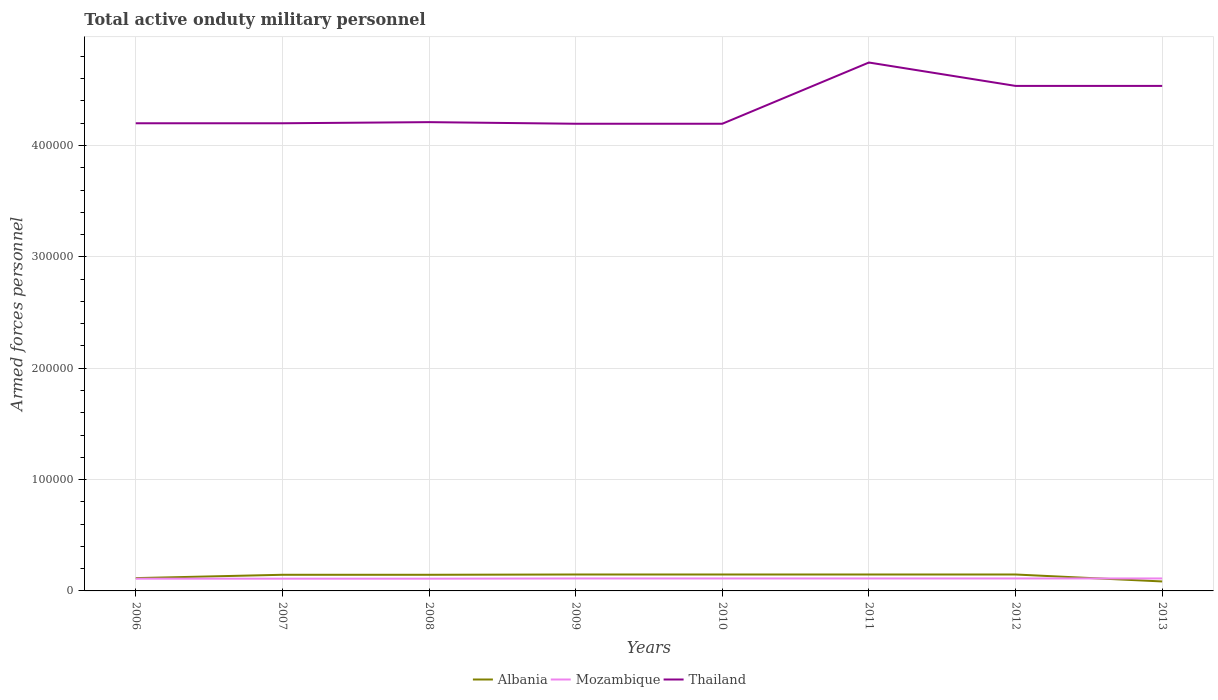How many different coloured lines are there?
Offer a very short reply. 3. Does the line corresponding to Mozambique intersect with the line corresponding to Albania?
Keep it short and to the point. Yes. Is the number of lines equal to the number of legend labels?
Your answer should be compact. Yes. Across all years, what is the maximum number of armed forces personnel in Albania?
Provide a short and direct response. 8500. What is the total number of armed forces personnel in Albania in the graph?
Provide a succinct answer. -3000. What is the difference between the highest and the second highest number of armed forces personnel in Albania?
Keep it short and to the point. 6250. How many lines are there?
Your answer should be very brief. 3. Are the values on the major ticks of Y-axis written in scientific E-notation?
Make the answer very short. No. What is the title of the graph?
Give a very brief answer. Total active onduty military personnel. Does "Bangladesh" appear as one of the legend labels in the graph?
Make the answer very short. No. What is the label or title of the X-axis?
Your answer should be very brief. Years. What is the label or title of the Y-axis?
Give a very brief answer. Armed forces personnel. What is the Armed forces personnel in Albania in 2006?
Offer a terse response. 1.15e+04. What is the Armed forces personnel in Mozambique in 2006?
Your answer should be compact. 1.10e+04. What is the Armed forces personnel of Albania in 2007?
Provide a short and direct response. 1.45e+04. What is the Armed forces personnel of Mozambique in 2007?
Offer a terse response. 1.10e+04. What is the Armed forces personnel in Thailand in 2007?
Keep it short and to the point. 4.20e+05. What is the Armed forces personnel of Albania in 2008?
Your response must be concise. 1.45e+04. What is the Armed forces personnel of Mozambique in 2008?
Ensure brevity in your answer.  1.10e+04. What is the Armed forces personnel of Thailand in 2008?
Provide a succinct answer. 4.21e+05. What is the Armed forces personnel in Albania in 2009?
Provide a succinct answer. 1.47e+04. What is the Armed forces personnel in Mozambique in 2009?
Your response must be concise. 1.12e+04. What is the Armed forces personnel in Thailand in 2009?
Ensure brevity in your answer.  4.20e+05. What is the Armed forces personnel in Albania in 2010?
Ensure brevity in your answer.  1.47e+04. What is the Armed forces personnel in Mozambique in 2010?
Provide a short and direct response. 1.12e+04. What is the Armed forces personnel in Thailand in 2010?
Offer a terse response. 4.20e+05. What is the Armed forces personnel in Albania in 2011?
Provide a short and direct response. 1.48e+04. What is the Armed forces personnel in Mozambique in 2011?
Your response must be concise. 1.12e+04. What is the Armed forces personnel of Thailand in 2011?
Ensure brevity in your answer.  4.75e+05. What is the Armed forces personnel in Albania in 2012?
Ensure brevity in your answer.  1.48e+04. What is the Armed forces personnel of Mozambique in 2012?
Offer a very short reply. 1.12e+04. What is the Armed forces personnel in Thailand in 2012?
Keep it short and to the point. 4.54e+05. What is the Armed forces personnel of Albania in 2013?
Provide a succinct answer. 8500. What is the Armed forces personnel of Mozambique in 2013?
Ensure brevity in your answer.  1.12e+04. What is the Armed forces personnel of Thailand in 2013?
Your response must be concise. 4.54e+05. Across all years, what is the maximum Armed forces personnel in Albania?
Ensure brevity in your answer.  1.48e+04. Across all years, what is the maximum Armed forces personnel of Mozambique?
Provide a succinct answer. 1.12e+04. Across all years, what is the maximum Armed forces personnel of Thailand?
Your answer should be compact. 4.75e+05. Across all years, what is the minimum Armed forces personnel in Albania?
Provide a succinct answer. 8500. Across all years, what is the minimum Armed forces personnel in Mozambique?
Your answer should be very brief. 1.10e+04. Across all years, what is the minimum Armed forces personnel of Thailand?
Offer a terse response. 4.20e+05. What is the total Armed forces personnel of Albania in the graph?
Make the answer very short. 1.08e+05. What is the total Armed forces personnel of Mozambique in the graph?
Offer a terse response. 8.90e+04. What is the total Armed forces personnel in Thailand in the graph?
Offer a very short reply. 3.48e+06. What is the difference between the Armed forces personnel of Albania in 2006 and that in 2007?
Give a very brief answer. -3000. What is the difference between the Armed forces personnel of Mozambique in 2006 and that in 2007?
Your answer should be compact. 0. What is the difference between the Armed forces personnel in Thailand in 2006 and that in 2007?
Your response must be concise. 0. What is the difference between the Armed forces personnel in Albania in 2006 and that in 2008?
Your answer should be very brief. -3000. What is the difference between the Armed forces personnel in Mozambique in 2006 and that in 2008?
Your answer should be very brief. 0. What is the difference between the Armed forces personnel of Thailand in 2006 and that in 2008?
Provide a succinct answer. -1000. What is the difference between the Armed forces personnel in Albania in 2006 and that in 2009?
Provide a succinct answer. -3245. What is the difference between the Armed forces personnel in Mozambique in 2006 and that in 2009?
Provide a succinct answer. -200. What is the difference between the Armed forces personnel of Thailand in 2006 and that in 2009?
Give a very brief answer. 440. What is the difference between the Armed forces personnel of Albania in 2006 and that in 2010?
Keep it short and to the point. -3245. What is the difference between the Armed forces personnel of Mozambique in 2006 and that in 2010?
Ensure brevity in your answer.  -200. What is the difference between the Armed forces personnel in Thailand in 2006 and that in 2010?
Offer a very short reply. 440. What is the difference between the Armed forces personnel of Albania in 2006 and that in 2011?
Your answer should be compact. -3250. What is the difference between the Armed forces personnel of Mozambique in 2006 and that in 2011?
Provide a succinct answer. -200. What is the difference between the Armed forces personnel of Thailand in 2006 and that in 2011?
Offer a terse response. -5.46e+04. What is the difference between the Armed forces personnel in Albania in 2006 and that in 2012?
Offer a very short reply. -3250. What is the difference between the Armed forces personnel of Mozambique in 2006 and that in 2012?
Keep it short and to the point. -200. What is the difference between the Armed forces personnel in Thailand in 2006 and that in 2012?
Your answer should be very brief. -3.36e+04. What is the difference between the Armed forces personnel of Albania in 2006 and that in 2013?
Ensure brevity in your answer.  3000. What is the difference between the Armed forces personnel in Mozambique in 2006 and that in 2013?
Give a very brief answer. -200. What is the difference between the Armed forces personnel of Thailand in 2006 and that in 2013?
Give a very brief answer. -3.36e+04. What is the difference between the Armed forces personnel of Albania in 2007 and that in 2008?
Your answer should be very brief. 0. What is the difference between the Armed forces personnel in Mozambique in 2007 and that in 2008?
Ensure brevity in your answer.  0. What is the difference between the Armed forces personnel of Thailand in 2007 and that in 2008?
Your answer should be very brief. -1000. What is the difference between the Armed forces personnel in Albania in 2007 and that in 2009?
Ensure brevity in your answer.  -245. What is the difference between the Armed forces personnel of Mozambique in 2007 and that in 2009?
Your answer should be compact. -200. What is the difference between the Armed forces personnel in Thailand in 2007 and that in 2009?
Offer a terse response. 440. What is the difference between the Armed forces personnel of Albania in 2007 and that in 2010?
Make the answer very short. -245. What is the difference between the Armed forces personnel in Mozambique in 2007 and that in 2010?
Provide a short and direct response. -200. What is the difference between the Armed forces personnel of Thailand in 2007 and that in 2010?
Keep it short and to the point. 440. What is the difference between the Armed forces personnel in Albania in 2007 and that in 2011?
Your answer should be very brief. -250. What is the difference between the Armed forces personnel of Mozambique in 2007 and that in 2011?
Ensure brevity in your answer.  -200. What is the difference between the Armed forces personnel of Thailand in 2007 and that in 2011?
Keep it short and to the point. -5.46e+04. What is the difference between the Armed forces personnel of Albania in 2007 and that in 2012?
Keep it short and to the point. -250. What is the difference between the Armed forces personnel in Mozambique in 2007 and that in 2012?
Offer a terse response. -200. What is the difference between the Armed forces personnel of Thailand in 2007 and that in 2012?
Provide a succinct answer. -3.36e+04. What is the difference between the Armed forces personnel in Albania in 2007 and that in 2013?
Provide a succinct answer. 6000. What is the difference between the Armed forces personnel of Mozambique in 2007 and that in 2013?
Ensure brevity in your answer.  -200. What is the difference between the Armed forces personnel in Thailand in 2007 and that in 2013?
Give a very brief answer. -3.36e+04. What is the difference between the Armed forces personnel of Albania in 2008 and that in 2009?
Your answer should be compact. -245. What is the difference between the Armed forces personnel of Mozambique in 2008 and that in 2009?
Provide a succinct answer. -200. What is the difference between the Armed forces personnel of Thailand in 2008 and that in 2009?
Your answer should be very brief. 1440. What is the difference between the Armed forces personnel of Albania in 2008 and that in 2010?
Your response must be concise. -245. What is the difference between the Armed forces personnel of Mozambique in 2008 and that in 2010?
Provide a succinct answer. -200. What is the difference between the Armed forces personnel in Thailand in 2008 and that in 2010?
Give a very brief answer. 1440. What is the difference between the Armed forces personnel in Albania in 2008 and that in 2011?
Your answer should be compact. -250. What is the difference between the Armed forces personnel in Mozambique in 2008 and that in 2011?
Give a very brief answer. -200. What is the difference between the Armed forces personnel of Thailand in 2008 and that in 2011?
Make the answer very short. -5.36e+04. What is the difference between the Armed forces personnel of Albania in 2008 and that in 2012?
Offer a terse response. -250. What is the difference between the Armed forces personnel of Mozambique in 2008 and that in 2012?
Offer a very short reply. -200. What is the difference between the Armed forces personnel of Thailand in 2008 and that in 2012?
Offer a terse response. -3.26e+04. What is the difference between the Armed forces personnel in Albania in 2008 and that in 2013?
Make the answer very short. 6000. What is the difference between the Armed forces personnel in Mozambique in 2008 and that in 2013?
Your answer should be very brief. -200. What is the difference between the Armed forces personnel in Thailand in 2008 and that in 2013?
Make the answer very short. -3.26e+04. What is the difference between the Armed forces personnel of Mozambique in 2009 and that in 2010?
Make the answer very short. 0. What is the difference between the Armed forces personnel in Mozambique in 2009 and that in 2011?
Provide a short and direct response. 0. What is the difference between the Armed forces personnel of Thailand in 2009 and that in 2011?
Offer a terse response. -5.50e+04. What is the difference between the Armed forces personnel of Thailand in 2009 and that in 2012?
Keep it short and to the point. -3.40e+04. What is the difference between the Armed forces personnel of Albania in 2009 and that in 2013?
Offer a very short reply. 6245. What is the difference between the Armed forces personnel in Mozambique in 2009 and that in 2013?
Give a very brief answer. 0. What is the difference between the Armed forces personnel of Thailand in 2009 and that in 2013?
Make the answer very short. -3.40e+04. What is the difference between the Armed forces personnel of Thailand in 2010 and that in 2011?
Keep it short and to the point. -5.50e+04. What is the difference between the Armed forces personnel of Thailand in 2010 and that in 2012?
Offer a very short reply. -3.40e+04. What is the difference between the Armed forces personnel of Albania in 2010 and that in 2013?
Keep it short and to the point. 6245. What is the difference between the Armed forces personnel of Mozambique in 2010 and that in 2013?
Make the answer very short. 0. What is the difference between the Armed forces personnel in Thailand in 2010 and that in 2013?
Your answer should be very brief. -3.40e+04. What is the difference between the Armed forces personnel in Albania in 2011 and that in 2012?
Your response must be concise. 0. What is the difference between the Armed forces personnel of Mozambique in 2011 and that in 2012?
Offer a very short reply. 0. What is the difference between the Armed forces personnel of Thailand in 2011 and that in 2012?
Make the answer very short. 2.10e+04. What is the difference between the Armed forces personnel in Albania in 2011 and that in 2013?
Give a very brief answer. 6250. What is the difference between the Armed forces personnel of Thailand in 2011 and that in 2013?
Keep it short and to the point. 2.10e+04. What is the difference between the Armed forces personnel of Albania in 2012 and that in 2013?
Make the answer very short. 6250. What is the difference between the Armed forces personnel in Mozambique in 2012 and that in 2013?
Provide a succinct answer. 0. What is the difference between the Armed forces personnel of Thailand in 2012 and that in 2013?
Offer a very short reply. 0. What is the difference between the Armed forces personnel in Albania in 2006 and the Armed forces personnel in Thailand in 2007?
Your answer should be very brief. -4.08e+05. What is the difference between the Armed forces personnel in Mozambique in 2006 and the Armed forces personnel in Thailand in 2007?
Provide a succinct answer. -4.09e+05. What is the difference between the Armed forces personnel of Albania in 2006 and the Armed forces personnel of Mozambique in 2008?
Make the answer very short. 500. What is the difference between the Armed forces personnel of Albania in 2006 and the Armed forces personnel of Thailand in 2008?
Your answer should be very brief. -4.10e+05. What is the difference between the Armed forces personnel in Mozambique in 2006 and the Armed forces personnel in Thailand in 2008?
Your response must be concise. -4.10e+05. What is the difference between the Armed forces personnel of Albania in 2006 and the Armed forces personnel of Mozambique in 2009?
Your response must be concise. 300. What is the difference between the Armed forces personnel of Albania in 2006 and the Armed forces personnel of Thailand in 2009?
Your answer should be very brief. -4.08e+05. What is the difference between the Armed forces personnel in Mozambique in 2006 and the Armed forces personnel in Thailand in 2009?
Your response must be concise. -4.09e+05. What is the difference between the Armed forces personnel in Albania in 2006 and the Armed forces personnel in Mozambique in 2010?
Your answer should be very brief. 300. What is the difference between the Armed forces personnel of Albania in 2006 and the Armed forces personnel of Thailand in 2010?
Offer a very short reply. -4.08e+05. What is the difference between the Armed forces personnel in Mozambique in 2006 and the Armed forces personnel in Thailand in 2010?
Keep it short and to the point. -4.09e+05. What is the difference between the Armed forces personnel of Albania in 2006 and the Armed forces personnel of Mozambique in 2011?
Offer a terse response. 300. What is the difference between the Armed forces personnel in Albania in 2006 and the Armed forces personnel in Thailand in 2011?
Your answer should be very brief. -4.63e+05. What is the difference between the Armed forces personnel of Mozambique in 2006 and the Armed forces personnel of Thailand in 2011?
Ensure brevity in your answer.  -4.64e+05. What is the difference between the Armed forces personnel of Albania in 2006 and the Armed forces personnel of Mozambique in 2012?
Provide a short and direct response. 300. What is the difference between the Armed forces personnel of Albania in 2006 and the Armed forces personnel of Thailand in 2012?
Offer a terse response. -4.42e+05. What is the difference between the Armed forces personnel of Mozambique in 2006 and the Armed forces personnel of Thailand in 2012?
Ensure brevity in your answer.  -4.43e+05. What is the difference between the Armed forces personnel of Albania in 2006 and the Armed forces personnel of Mozambique in 2013?
Provide a succinct answer. 300. What is the difference between the Armed forces personnel of Albania in 2006 and the Armed forces personnel of Thailand in 2013?
Provide a short and direct response. -4.42e+05. What is the difference between the Armed forces personnel in Mozambique in 2006 and the Armed forces personnel in Thailand in 2013?
Keep it short and to the point. -4.43e+05. What is the difference between the Armed forces personnel of Albania in 2007 and the Armed forces personnel of Mozambique in 2008?
Give a very brief answer. 3500. What is the difference between the Armed forces personnel of Albania in 2007 and the Armed forces personnel of Thailand in 2008?
Offer a terse response. -4.06e+05. What is the difference between the Armed forces personnel in Mozambique in 2007 and the Armed forces personnel in Thailand in 2008?
Your answer should be compact. -4.10e+05. What is the difference between the Armed forces personnel in Albania in 2007 and the Armed forces personnel in Mozambique in 2009?
Offer a very short reply. 3300. What is the difference between the Armed forces personnel of Albania in 2007 and the Armed forces personnel of Thailand in 2009?
Your answer should be compact. -4.05e+05. What is the difference between the Armed forces personnel in Mozambique in 2007 and the Armed forces personnel in Thailand in 2009?
Offer a terse response. -4.09e+05. What is the difference between the Armed forces personnel in Albania in 2007 and the Armed forces personnel in Mozambique in 2010?
Offer a very short reply. 3300. What is the difference between the Armed forces personnel in Albania in 2007 and the Armed forces personnel in Thailand in 2010?
Ensure brevity in your answer.  -4.05e+05. What is the difference between the Armed forces personnel in Mozambique in 2007 and the Armed forces personnel in Thailand in 2010?
Your response must be concise. -4.09e+05. What is the difference between the Armed forces personnel of Albania in 2007 and the Armed forces personnel of Mozambique in 2011?
Offer a terse response. 3300. What is the difference between the Armed forces personnel in Albania in 2007 and the Armed forces personnel in Thailand in 2011?
Provide a short and direct response. -4.60e+05. What is the difference between the Armed forces personnel in Mozambique in 2007 and the Armed forces personnel in Thailand in 2011?
Offer a terse response. -4.64e+05. What is the difference between the Armed forces personnel of Albania in 2007 and the Armed forces personnel of Mozambique in 2012?
Your answer should be compact. 3300. What is the difference between the Armed forces personnel of Albania in 2007 and the Armed forces personnel of Thailand in 2012?
Ensure brevity in your answer.  -4.39e+05. What is the difference between the Armed forces personnel in Mozambique in 2007 and the Armed forces personnel in Thailand in 2012?
Offer a terse response. -4.43e+05. What is the difference between the Armed forces personnel in Albania in 2007 and the Armed forces personnel in Mozambique in 2013?
Ensure brevity in your answer.  3300. What is the difference between the Armed forces personnel of Albania in 2007 and the Armed forces personnel of Thailand in 2013?
Ensure brevity in your answer.  -4.39e+05. What is the difference between the Armed forces personnel in Mozambique in 2007 and the Armed forces personnel in Thailand in 2013?
Give a very brief answer. -4.43e+05. What is the difference between the Armed forces personnel in Albania in 2008 and the Armed forces personnel in Mozambique in 2009?
Provide a succinct answer. 3300. What is the difference between the Armed forces personnel in Albania in 2008 and the Armed forces personnel in Thailand in 2009?
Keep it short and to the point. -4.05e+05. What is the difference between the Armed forces personnel in Mozambique in 2008 and the Armed forces personnel in Thailand in 2009?
Your answer should be very brief. -4.09e+05. What is the difference between the Armed forces personnel of Albania in 2008 and the Armed forces personnel of Mozambique in 2010?
Ensure brevity in your answer.  3300. What is the difference between the Armed forces personnel in Albania in 2008 and the Armed forces personnel in Thailand in 2010?
Your answer should be compact. -4.05e+05. What is the difference between the Armed forces personnel in Mozambique in 2008 and the Armed forces personnel in Thailand in 2010?
Your response must be concise. -4.09e+05. What is the difference between the Armed forces personnel of Albania in 2008 and the Armed forces personnel of Mozambique in 2011?
Provide a succinct answer. 3300. What is the difference between the Armed forces personnel in Albania in 2008 and the Armed forces personnel in Thailand in 2011?
Provide a short and direct response. -4.60e+05. What is the difference between the Armed forces personnel in Mozambique in 2008 and the Armed forces personnel in Thailand in 2011?
Give a very brief answer. -4.64e+05. What is the difference between the Armed forces personnel of Albania in 2008 and the Armed forces personnel of Mozambique in 2012?
Provide a short and direct response. 3300. What is the difference between the Armed forces personnel of Albania in 2008 and the Armed forces personnel of Thailand in 2012?
Provide a succinct answer. -4.39e+05. What is the difference between the Armed forces personnel of Mozambique in 2008 and the Armed forces personnel of Thailand in 2012?
Offer a terse response. -4.43e+05. What is the difference between the Armed forces personnel of Albania in 2008 and the Armed forces personnel of Mozambique in 2013?
Ensure brevity in your answer.  3300. What is the difference between the Armed forces personnel of Albania in 2008 and the Armed forces personnel of Thailand in 2013?
Offer a terse response. -4.39e+05. What is the difference between the Armed forces personnel in Mozambique in 2008 and the Armed forces personnel in Thailand in 2013?
Your answer should be very brief. -4.43e+05. What is the difference between the Armed forces personnel in Albania in 2009 and the Armed forces personnel in Mozambique in 2010?
Provide a short and direct response. 3545. What is the difference between the Armed forces personnel in Albania in 2009 and the Armed forces personnel in Thailand in 2010?
Offer a very short reply. -4.05e+05. What is the difference between the Armed forces personnel in Mozambique in 2009 and the Armed forces personnel in Thailand in 2010?
Give a very brief answer. -4.08e+05. What is the difference between the Armed forces personnel in Albania in 2009 and the Armed forces personnel in Mozambique in 2011?
Keep it short and to the point. 3545. What is the difference between the Armed forces personnel in Albania in 2009 and the Armed forces personnel in Thailand in 2011?
Your response must be concise. -4.60e+05. What is the difference between the Armed forces personnel in Mozambique in 2009 and the Armed forces personnel in Thailand in 2011?
Offer a terse response. -4.63e+05. What is the difference between the Armed forces personnel of Albania in 2009 and the Armed forces personnel of Mozambique in 2012?
Offer a very short reply. 3545. What is the difference between the Armed forces personnel in Albania in 2009 and the Armed forces personnel in Thailand in 2012?
Make the answer very short. -4.39e+05. What is the difference between the Armed forces personnel in Mozambique in 2009 and the Armed forces personnel in Thailand in 2012?
Provide a succinct answer. -4.42e+05. What is the difference between the Armed forces personnel of Albania in 2009 and the Armed forces personnel of Mozambique in 2013?
Your answer should be very brief. 3545. What is the difference between the Armed forces personnel in Albania in 2009 and the Armed forces personnel in Thailand in 2013?
Your response must be concise. -4.39e+05. What is the difference between the Armed forces personnel in Mozambique in 2009 and the Armed forces personnel in Thailand in 2013?
Your response must be concise. -4.42e+05. What is the difference between the Armed forces personnel of Albania in 2010 and the Armed forces personnel of Mozambique in 2011?
Ensure brevity in your answer.  3545. What is the difference between the Armed forces personnel in Albania in 2010 and the Armed forces personnel in Thailand in 2011?
Provide a short and direct response. -4.60e+05. What is the difference between the Armed forces personnel of Mozambique in 2010 and the Armed forces personnel of Thailand in 2011?
Ensure brevity in your answer.  -4.63e+05. What is the difference between the Armed forces personnel of Albania in 2010 and the Armed forces personnel of Mozambique in 2012?
Offer a very short reply. 3545. What is the difference between the Armed forces personnel in Albania in 2010 and the Armed forces personnel in Thailand in 2012?
Your answer should be compact. -4.39e+05. What is the difference between the Armed forces personnel of Mozambique in 2010 and the Armed forces personnel of Thailand in 2012?
Your answer should be compact. -4.42e+05. What is the difference between the Armed forces personnel in Albania in 2010 and the Armed forces personnel in Mozambique in 2013?
Your answer should be very brief. 3545. What is the difference between the Armed forces personnel of Albania in 2010 and the Armed forces personnel of Thailand in 2013?
Your answer should be compact. -4.39e+05. What is the difference between the Armed forces personnel of Mozambique in 2010 and the Armed forces personnel of Thailand in 2013?
Provide a succinct answer. -4.42e+05. What is the difference between the Armed forces personnel of Albania in 2011 and the Armed forces personnel of Mozambique in 2012?
Provide a succinct answer. 3550. What is the difference between the Armed forces personnel in Albania in 2011 and the Armed forces personnel in Thailand in 2012?
Give a very brief answer. -4.39e+05. What is the difference between the Armed forces personnel in Mozambique in 2011 and the Armed forces personnel in Thailand in 2012?
Provide a succinct answer. -4.42e+05. What is the difference between the Armed forces personnel in Albania in 2011 and the Armed forces personnel in Mozambique in 2013?
Make the answer very short. 3550. What is the difference between the Armed forces personnel in Albania in 2011 and the Armed forces personnel in Thailand in 2013?
Offer a very short reply. -4.39e+05. What is the difference between the Armed forces personnel in Mozambique in 2011 and the Armed forces personnel in Thailand in 2013?
Your response must be concise. -4.42e+05. What is the difference between the Armed forces personnel of Albania in 2012 and the Armed forces personnel of Mozambique in 2013?
Provide a short and direct response. 3550. What is the difference between the Armed forces personnel in Albania in 2012 and the Armed forces personnel in Thailand in 2013?
Give a very brief answer. -4.39e+05. What is the difference between the Armed forces personnel of Mozambique in 2012 and the Armed forces personnel of Thailand in 2013?
Make the answer very short. -4.42e+05. What is the average Armed forces personnel of Albania per year?
Make the answer very short. 1.35e+04. What is the average Armed forces personnel in Mozambique per year?
Your answer should be compact. 1.11e+04. What is the average Armed forces personnel of Thailand per year?
Ensure brevity in your answer.  4.35e+05. In the year 2006, what is the difference between the Armed forces personnel of Albania and Armed forces personnel of Thailand?
Offer a terse response. -4.08e+05. In the year 2006, what is the difference between the Armed forces personnel of Mozambique and Armed forces personnel of Thailand?
Your response must be concise. -4.09e+05. In the year 2007, what is the difference between the Armed forces personnel of Albania and Armed forces personnel of Mozambique?
Make the answer very short. 3500. In the year 2007, what is the difference between the Armed forces personnel of Albania and Armed forces personnel of Thailand?
Your response must be concise. -4.06e+05. In the year 2007, what is the difference between the Armed forces personnel of Mozambique and Armed forces personnel of Thailand?
Your answer should be very brief. -4.09e+05. In the year 2008, what is the difference between the Armed forces personnel of Albania and Armed forces personnel of Mozambique?
Your response must be concise. 3500. In the year 2008, what is the difference between the Armed forces personnel of Albania and Armed forces personnel of Thailand?
Make the answer very short. -4.06e+05. In the year 2008, what is the difference between the Armed forces personnel in Mozambique and Armed forces personnel in Thailand?
Ensure brevity in your answer.  -4.10e+05. In the year 2009, what is the difference between the Armed forces personnel in Albania and Armed forces personnel in Mozambique?
Give a very brief answer. 3545. In the year 2009, what is the difference between the Armed forces personnel in Albania and Armed forces personnel in Thailand?
Provide a succinct answer. -4.05e+05. In the year 2009, what is the difference between the Armed forces personnel in Mozambique and Armed forces personnel in Thailand?
Give a very brief answer. -4.08e+05. In the year 2010, what is the difference between the Armed forces personnel in Albania and Armed forces personnel in Mozambique?
Your answer should be compact. 3545. In the year 2010, what is the difference between the Armed forces personnel in Albania and Armed forces personnel in Thailand?
Provide a succinct answer. -4.05e+05. In the year 2010, what is the difference between the Armed forces personnel of Mozambique and Armed forces personnel of Thailand?
Your response must be concise. -4.08e+05. In the year 2011, what is the difference between the Armed forces personnel of Albania and Armed forces personnel of Mozambique?
Your answer should be very brief. 3550. In the year 2011, what is the difference between the Armed forces personnel of Albania and Armed forces personnel of Thailand?
Provide a short and direct response. -4.60e+05. In the year 2011, what is the difference between the Armed forces personnel in Mozambique and Armed forces personnel in Thailand?
Your answer should be very brief. -4.63e+05. In the year 2012, what is the difference between the Armed forces personnel of Albania and Armed forces personnel of Mozambique?
Give a very brief answer. 3550. In the year 2012, what is the difference between the Armed forces personnel in Albania and Armed forces personnel in Thailand?
Ensure brevity in your answer.  -4.39e+05. In the year 2012, what is the difference between the Armed forces personnel in Mozambique and Armed forces personnel in Thailand?
Offer a very short reply. -4.42e+05. In the year 2013, what is the difference between the Armed forces personnel in Albania and Armed forces personnel in Mozambique?
Give a very brief answer. -2700. In the year 2013, what is the difference between the Armed forces personnel in Albania and Armed forces personnel in Thailand?
Offer a terse response. -4.45e+05. In the year 2013, what is the difference between the Armed forces personnel in Mozambique and Armed forces personnel in Thailand?
Your answer should be compact. -4.42e+05. What is the ratio of the Armed forces personnel in Albania in 2006 to that in 2007?
Your answer should be compact. 0.79. What is the ratio of the Armed forces personnel of Mozambique in 2006 to that in 2007?
Your answer should be very brief. 1. What is the ratio of the Armed forces personnel of Albania in 2006 to that in 2008?
Your response must be concise. 0.79. What is the ratio of the Armed forces personnel of Mozambique in 2006 to that in 2008?
Keep it short and to the point. 1. What is the ratio of the Armed forces personnel of Albania in 2006 to that in 2009?
Offer a very short reply. 0.78. What is the ratio of the Armed forces personnel of Mozambique in 2006 to that in 2009?
Offer a very short reply. 0.98. What is the ratio of the Armed forces personnel of Thailand in 2006 to that in 2009?
Provide a succinct answer. 1. What is the ratio of the Armed forces personnel of Albania in 2006 to that in 2010?
Make the answer very short. 0.78. What is the ratio of the Armed forces personnel of Mozambique in 2006 to that in 2010?
Provide a short and direct response. 0.98. What is the ratio of the Armed forces personnel of Thailand in 2006 to that in 2010?
Ensure brevity in your answer.  1. What is the ratio of the Armed forces personnel of Albania in 2006 to that in 2011?
Provide a short and direct response. 0.78. What is the ratio of the Armed forces personnel of Mozambique in 2006 to that in 2011?
Make the answer very short. 0.98. What is the ratio of the Armed forces personnel of Thailand in 2006 to that in 2011?
Give a very brief answer. 0.89. What is the ratio of the Armed forces personnel of Albania in 2006 to that in 2012?
Your response must be concise. 0.78. What is the ratio of the Armed forces personnel of Mozambique in 2006 to that in 2012?
Your answer should be compact. 0.98. What is the ratio of the Armed forces personnel in Thailand in 2006 to that in 2012?
Offer a very short reply. 0.93. What is the ratio of the Armed forces personnel of Albania in 2006 to that in 2013?
Ensure brevity in your answer.  1.35. What is the ratio of the Armed forces personnel in Mozambique in 2006 to that in 2013?
Offer a very short reply. 0.98. What is the ratio of the Armed forces personnel of Thailand in 2006 to that in 2013?
Your answer should be very brief. 0.93. What is the ratio of the Armed forces personnel of Albania in 2007 to that in 2008?
Provide a short and direct response. 1. What is the ratio of the Armed forces personnel of Thailand in 2007 to that in 2008?
Provide a short and direct response. 1. What is the ratio of the Armed forces personnel in Albania in 2007 to that in 2009?
Make the answer very short. 0.98. What is the ratio of the Armed forces personnel of Mozambique in 2007 to that in 2009?
Offer a very short reply. 0.98. What is the ratio of the Armed forces personnel of Albania in 2007 to that in 2010?
Keep it short and to the point. 0.98. What is the ratio of the Armed forces personnel of Mozambique in 2007 to that in 2010?
Your answer should be compact. 0.98. What is the ratio of the Armed forces personnel in Thailand in 2007 to that in 2010?
Offer a very short reply. 1. What is the ratio of the Armed forces personnel of Albania in 2007 to that in 2011?
Your answer should be very brief. 0.98. What is the ratio of the Armed forces personnel in Mozambique in 2007 to that in 2011?
Keep it short and to the point. 0.98. What is the ratio of the Armed forces personnel in Thailand in 2007 to that in 2011?
Your response must be concise. 0.89. What is the ratio of the Armed forces personnel in Albania in 2007 to that in 2012?
Your answer should be compact. 0.98. What is the ratio of the Armed forces personnel of Mozambique in 2007 to that in 2012?
Keep it short and to the point. 0.98. What is the ratio of the Armed forces personnel of Thailand in 2007 to that in 2012?
Give a very brief answer. 0.93. What is the ratio of the Armed forces personnel in Albania in 2007 to that in 2013?
Ensure brevity in your answer.  1.71. What is the ratio of the Armed forces personnel in Mozambique in 2007 to that in 2013?
Your answer should be compact. 0.98. What is the ratio of the Armed forces personnel in Thailand in 2007 to that in 2013?
Provide a short and direct response. 0.93. What is the ratio of the Armed forces personnel in Albania in 2008 to that in 2009?
Offer a terse response. 0.98. What is the ratio of the Armed forces personnel in Mozambique in 2008 to that in 2009?
Your response must be concise. 0.98. What is the ratio of the Armed forces personnel in Albania in 2008 to that in 2010?
Offer a terse response. 0.98. What is the ratio of the Armed forces personnel of Mozambique in 2008 to that in 2010?
Ensure brevity in your answer.  0.98. What is the ratio of the Armed forces personnel in Thailand in 2008 to that in 2010?
Provide a short and direct response. 1. What is the ratio of the Armed forces personnel of Albania in 2008 to that in 2011?
Make the answer very short. 0.98. What is the ratio of the Armed forces personnel of Mozambique in 2008 to that in 2011?
Offer a very short reply. 0.98. What is the ratio of the Armed forces personnel in Thailand in 2008 to that in 2011?
Ensure brevity in your answer.  0.89. What is the ratio of the Armed forces personnel in Albania in 2008 to that in 2012?
Provide a succinct answer. 0.98. What is the ratio of the Armed forces personnel in Mozambique in 2008 to that in 2012?
Offer a very short reply. 0.98. What is the ratio of the Armed forces personnel of Thailand in 2008 to that in 2012?
Give a very brief answer. 0.93. What is the ratio of the Armed forces personnel of Albania in 2008 to that in 2013?
Provide a succinct answer. 1.71. What is the ratio of the Armed forces personnel in Mozambique in 2008 to that in 2013?
Make the answer very short. 0.98. What is the ratio of the Armed forces personnel of Thailand in 2008 to that in 2013?
Keep it short and to the point. 0.93. What is the ratio of the Armed forces personnel in Albania in 2009 to that in 2010?
Give a very brief answer. 1. What is the ratio of the Armed forces personnel of Mozambique in 2009 to that in 2011?
Your answer should be compact. 1. What is the ratio of the Armed forces personnel in Thailand in 2009 to that in 2011?
Give a very brief answer. 0.88. What is the ratio of the Armed forces personnel in Mozambique in 2009 to that in 2012?
Offer a terse response. 1. What is the ratio of the Armed forces personnel in Thailand in 2009 to that in 2012?
Offer a terse response. 0.93. What is the ratio of the Armed forces personnel of Albania in 2009 to that in 2013?
Keep it short and to the point. 1.73. What is the ratio of the Armed forces personnel of Mozambique in 2009 to that in 2013?
Your answer should be compact. 1. What is the ratio of the Armed forces personnel in Thailand in 2009 to that in 2013?
Offer a very short reply. 0.93. What is the ratio of the Armed forces personnel in Thailand in 2010 to that in 2011?
Your answer should be compact. 0.88. What is the ratio of the Armed forces personnel of Albania in 2010 to that in 2012?
Give a very brief answer. 1. What is the ratio of the Armed forces personnel of Thailand in 2010 to that in 2012?
Your answer should be compact. 0.93. What is the ratio of the Armed forces personnel in Albania in 2010 to that in 2013?
Offer a very short reply. 1.73. What is the ratio of the Armed forces personnel in Mozambique in 2010 to that in 2013?
Make the answer very short. 1. What is the ratio of the Armed forces personnel in Thailand in 2010 to that in 2013?
Offer a terse response. 0.93. What is the ratio of the Armed forces personnel in Albania in 2011 to that in 2012?
Give a very brief answer. 1. What is the ratio of the Armed forces personnel in Mozambique in 2011 to that in 2012?
Your answer should be compact. 1. What is the ratio of the Armed forces personnel in Thailand in 2011 to that in 2012?
Keep it short and to the point. 1.05. What is the ratio of the Armed forces personnel of Albania in 2011 to that in 2013?
Ensure brevity in your answer.  1.74. What is the ratio of the Armed forces personnel in Thailand in 2011 to that in 2013?
Give a very brief answer. 1.05. What is the ratio of the Armed forces personnel of Albania in 2012 to that in 2013?
Offer a very short reply. 1.74. What is the ratio of the Armed forces personnel of Mozambique in 2012 to that in 2013?
Give a very brief answer. 1. What is the ratio of the Armed forces personnel in Thailand in 2012 to that in 2013?
Provide a short and direct response. 1. What is the difference between the highest and the second highest Armed forces personnel of Thailand?
Give a very brief answer. 2.10e+04. What is the difference between the highest and the lowest Armed forces personnel of Albania?
Keep it short and to the point. 6250. What is the difference between the highest and the lowest Armed forces personnel in Thailand?
Offer a terse response. 5.50e+04. 